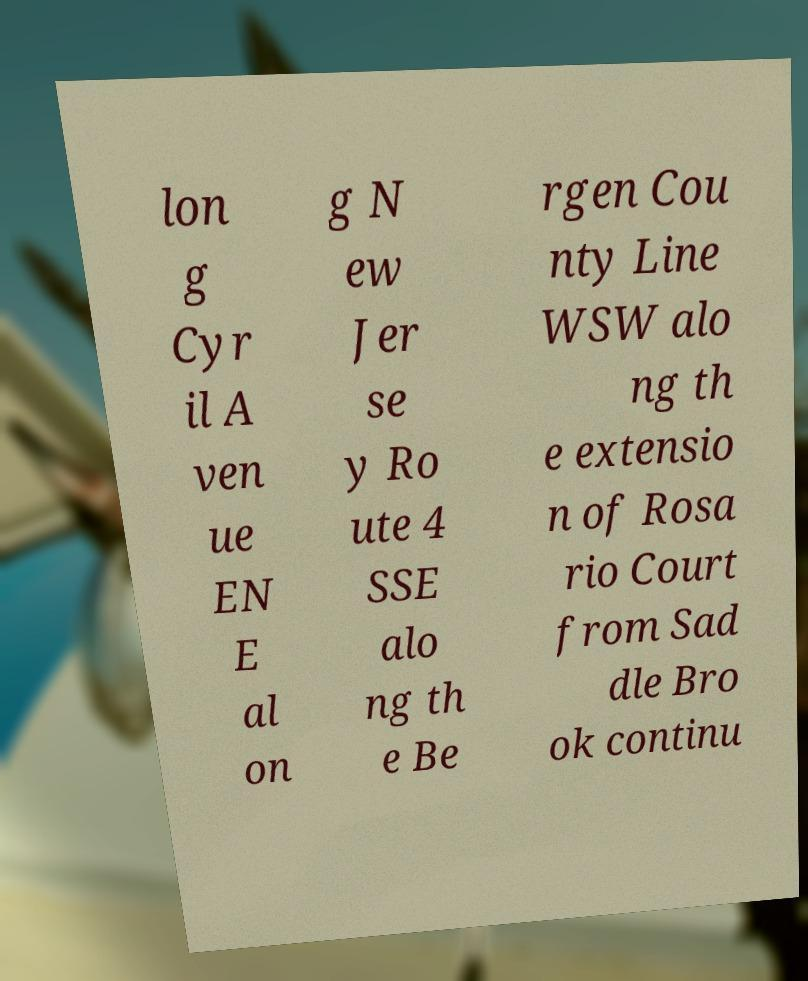Can you accurately transcribe the text from the provided image for me? lon g Cyr il A ven ue EN E al on g N ew Jer se y Ro ute 4 SSE alo ng th e Be rgen Cou nty Line WSW alo ng th e extensio n of Rosa rio Court from Sad dle Bro ok continu 